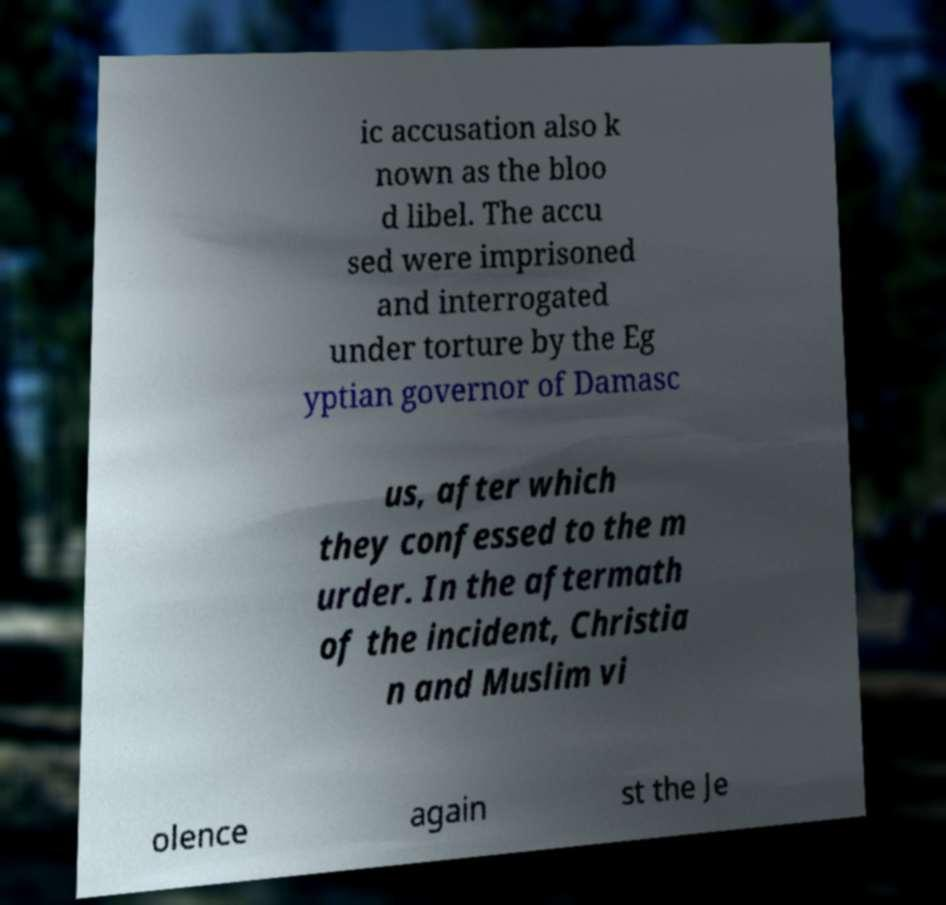Could you extract and type out the text from this image? ic accusation also k nown as the bloo d libel. The accu sed were imprisoned and interrogated under torture by the Eg yptian governor of Damasc us, after which they confessed to the m urder. In the aftermath of the incident, Christia n and Muslim vi olence again st the Je 